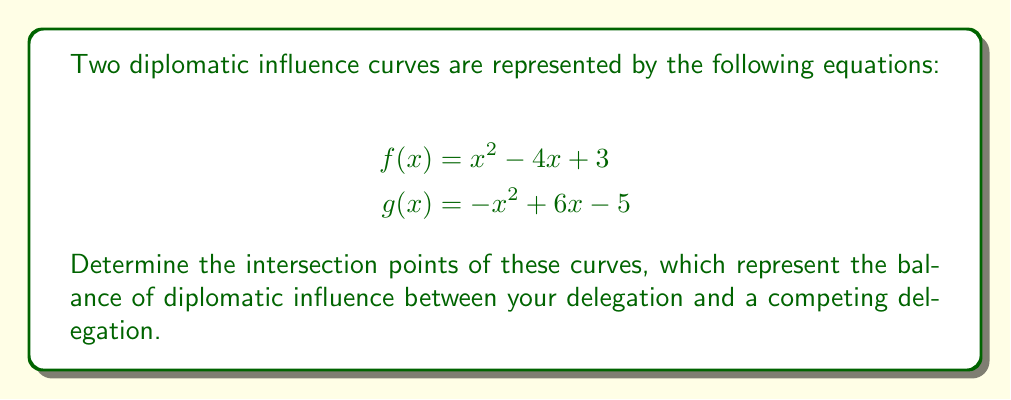Give your solution to this math problem. To find the intersection points, we need to solve the equation $f(x) = g(x)$:

1) Set up the equation:
   $x^2 - 4x + 3 = -x^2 + 6x - 5$

2) Rearrange terms to standard form:
   $x^2 - 4x + 3 + x^2 - 6x + 5 = 0$
   $2x^2 - 10x + 8 = 0$

3) Divide all terms by 2 to simplify:
   $x^2 - 5x + 4 = 0$

4) This is a quadratic equation. We can solve it using the quadratic formula:
   $x = \frac{-b \pm \sqrt{b^2 - 4ac}}{2a}$
   where $a=1$, $b=-5$, and $c=4$

5) Substitute into the formula:
   $x = \frac{5 \pm \sqrt{25 - 16}}{2} = \frac{5 \pm \sqrt{9}}{2} = \frac{5 \pm 3}{2}$

6) Solve:
   $x_1 = \frac{5 + 3}{2} = 4$
   $x_2 = \frac{5 - 3}{2} = 1$

7) To find the y-coordinates, substitute these x-values into either $f(x)$ or $g(x)$:
   For $x = 4$: $f(4) = 4^2 - 4(4) + 3 = 16 - 16 + 3 = 3$
   For $x = 1$: $f(1) = 1^2 - 4(1) + 3 = 1 - 4 + 3 = 0$

Therefore, the intersection points are (4, 3) and (1, 0).
Answer: (4, 3) and (1, 0) 